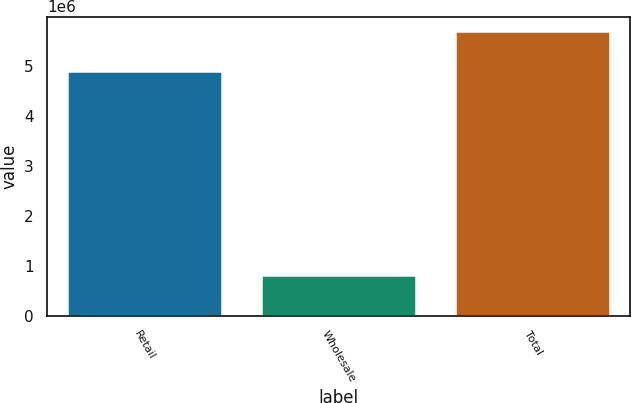Convert chart to OTSL. <chart><loc_0><loc_0><loc_500><loc_500><bar_chart><fcel>Retail<fcel>Wholesale<fcel>Total<nl><fcel>4.89468e+06<fcel>814706<fcel>5.70938e+06<nl></chart> 